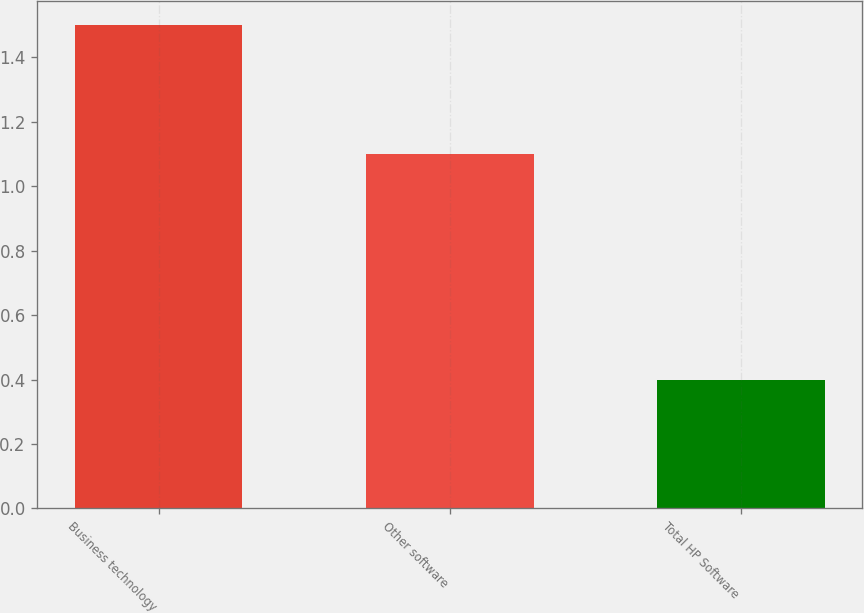<chart> <loc_0><loc_0><loc_500><loc_500><bar_chart><fcel>Business technology<fcel>Other software<fcel>Total HP Software<nl><fcel>1.5<fcel>1.1<fcel>0.4<nl></chart> 